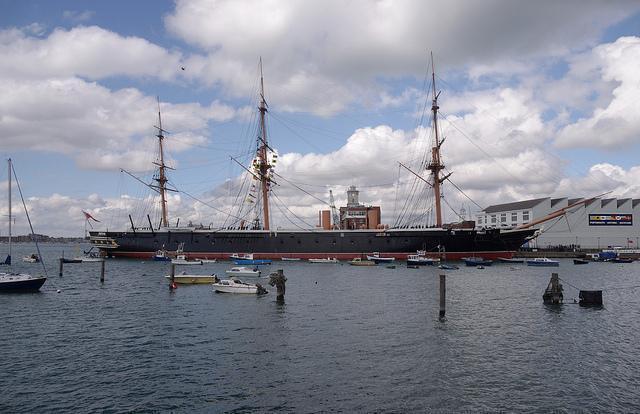How many boats are there?
Give a very brief answer. 2. 